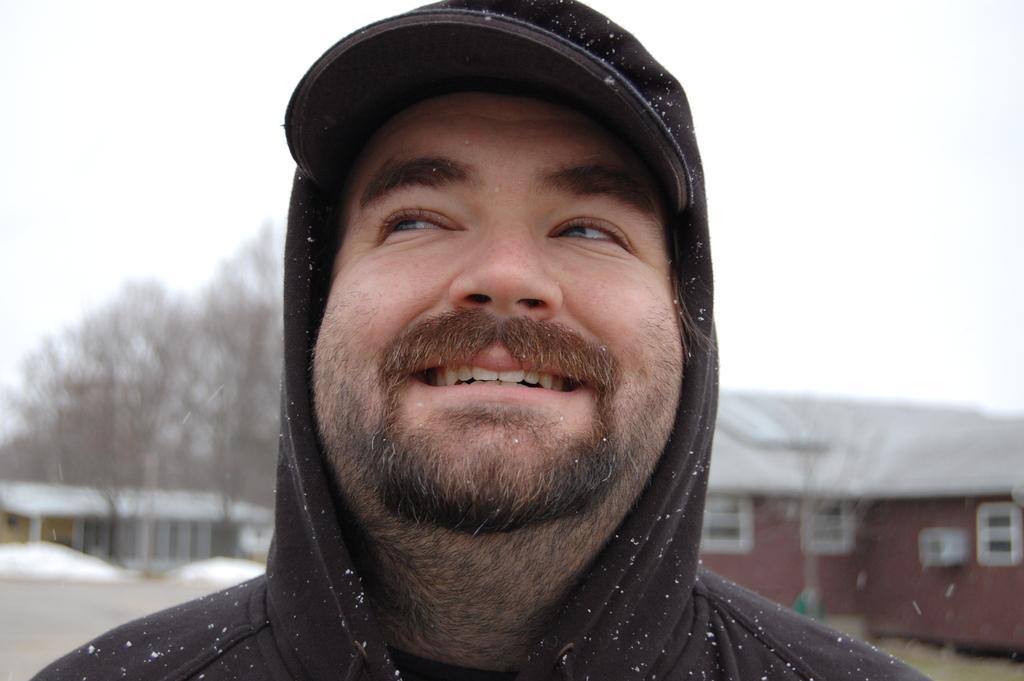In one or two sentences, can you explain what this image depicts? In the middle of the image we can see a man, he wore a cap and he is smiling, behind him we can see few buildings, trees and snow. 